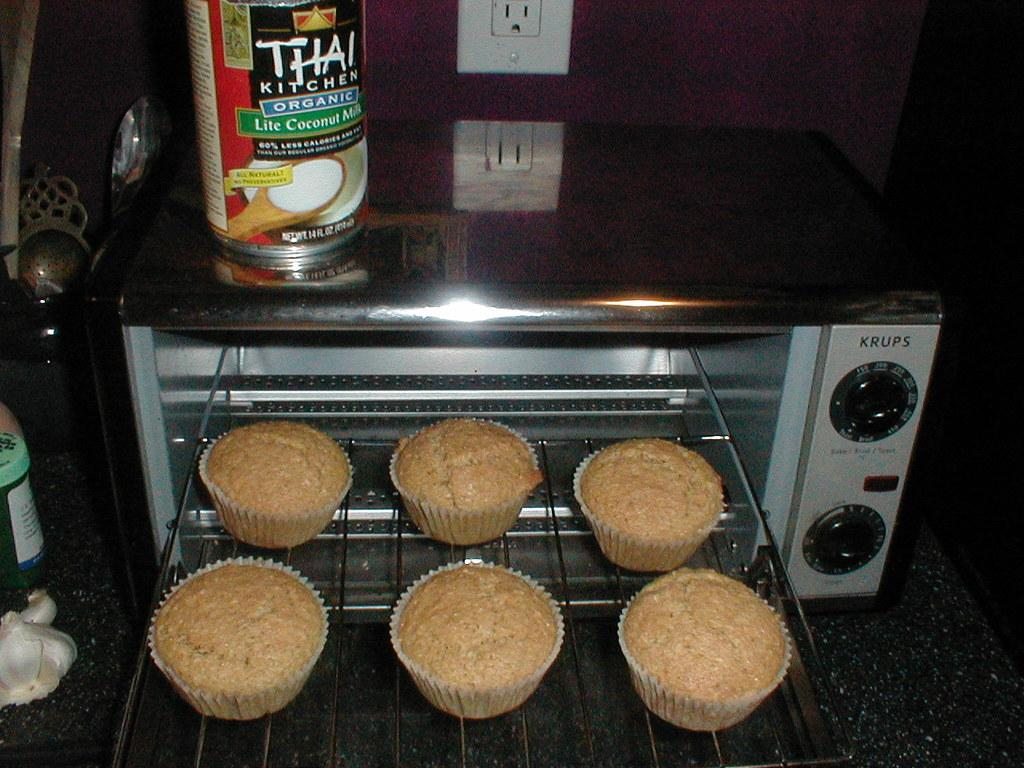Provide a one-sentence caption for the provided image. krups toaster oven with muffins coming out of it and a container of lite coconut milk above. 